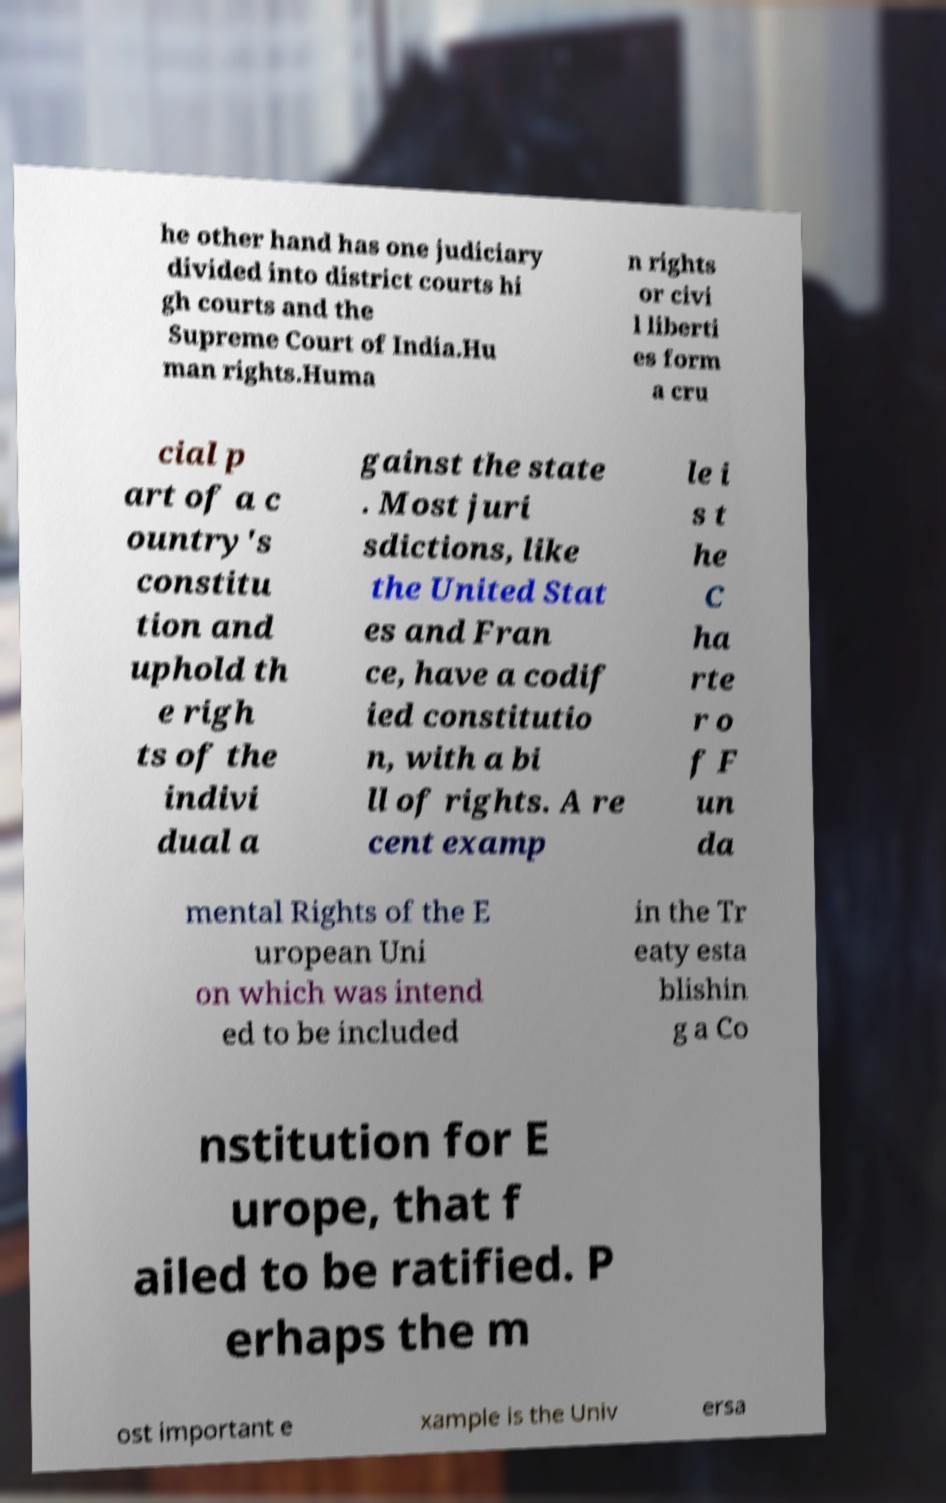For documentation purposes, I need the text within this image transcribed. Could you provide that? he other hand has one judiciary divided into district courts hi gh courts and the Supreme Court of India.Hu man rights.Huma n rights or civi l liberti es form a cru cial p art of a c ountry's constitu tion and uphold th e righ ts of the indivi dual a gainst the state . Most juri sdictions, like the United Stat es and Fran ce, have a codif ied constitutio n, with a bi ll of rights. A re cent examp le i s t he C ha rte r o f F un da mental Rights of the E uropean Uni on which was intend ed to be included in the Tr eaty esta blishin g a Co nstitution for E urope, that f ailed to be ratified. P erhaps the m ost important e xample is the Univ ersa 